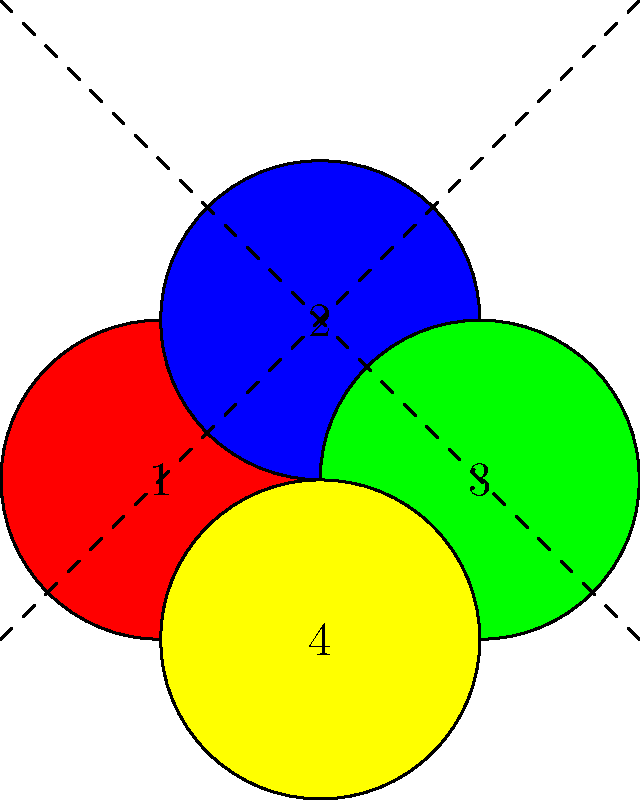For your luxurious bathroom floor, you're designing an intricate tile mosaic using diamond-shaped tiles. The pattern consists of four colored tiles arranged as shown in the diagram. To create a larger pattern, you need to apply a series of transformations to this basic unit. If you first reflect the unit over the diagonal line from top-left to bottom-right, then rotate the result 90° clockwise around the center point, and finally translate it 2 units to the right and 2 units up, what will be the final position and orientation of tile 3 (the green tile)? Let's break this down step-by-step:

1) First, we reflect over the diagonal line from top-left to bottom-right:
   - This swaps tiles 1 and 3, and leaves 2 and 4 in place.
   - Tile 3 (green) is now in the position of tile 1.

2) Next, we rotate 90° clockwise around the center point:
   - This moves each tile to the next corner clockwise.
   - Tile 3, which was in position 1, now moves to position 4.

3) Finally, we translate 2 units right and 2 units up:
   - This shifts the entire pattern.
   - Tile 3, which was in position 4, moves 2 units right and 2 units up from that position.

To determine the final position, let's use the center of the original pattern as our reference point (0,0):
   - Position 4 in the original pattern is at (1,-1) relative to the center.
   - After translation, this becomes (3,1).

The orientation of tile 3 after these transformations:
   - The reflection flips it horizontally.
   - The 90° rotation then turns this horizontally flipped tile 90° clockwise.

Therefore, tile 3 ends up at position (3,1) relative to the original center, rotated 90° clockwise from its original orientation.
Answer: Position: (3,1), rotated 90° clockwise from original orientation 